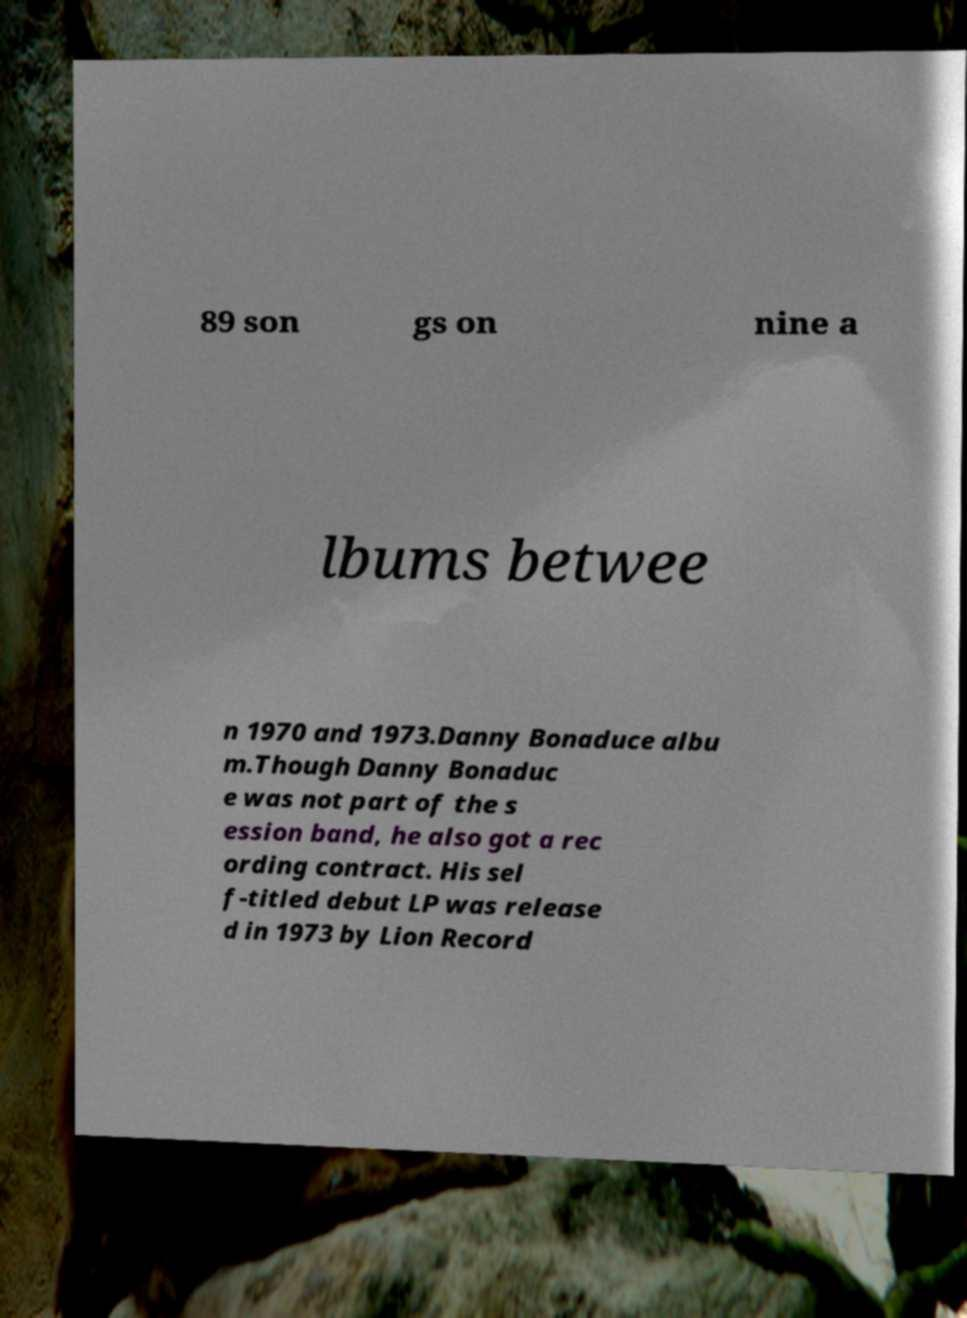Can you accurately transcribe the text from the provided image for me? 89 son gs on nine a lbums betwee n 1970 and 1973.Danny Bonaduce albu m.Though Danny Bonaduc e was not part of the s ession band, he also got a rec ording contract. His sel f-titled debut LP was release d in 1973 by Lion Record 